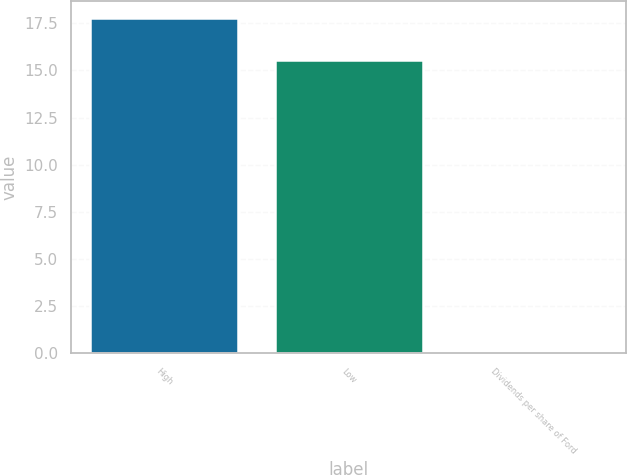<chart> <loc_0><loc_0><loc_500><loc_500><bar_chart><fcel>High<fcel>Low<fcel>Dividends per share of Ford<nl><fcel>17.77<fcel>15.56<fcel>0.1<nl></chart> 